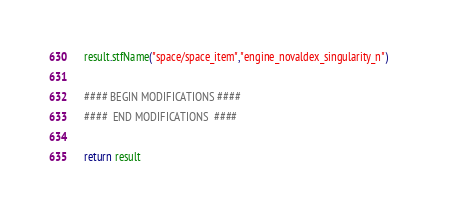Convert code to text. <code><loc_0><loc_0><loc_500><loc_500><_Python_>	result.stfName("space/space_item","engine_novaldex_singularity_n")		
	
	#### BEGIN MODIFICATIONS ####
	####  END MODIFICATIONS  ####
	
	return result</code> 